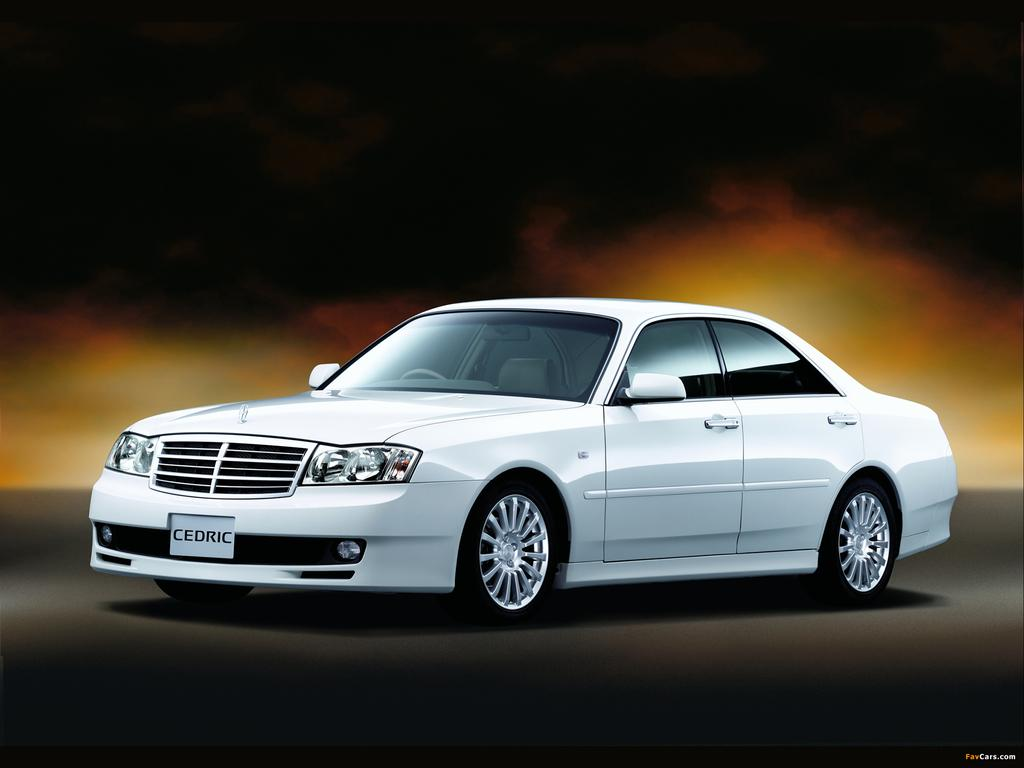What color is the car in the image? The car in the image is white. Where is the car located in the image? The car is parked on the ground. What can be observed about the background of the image? The background of the image is dark. How does the car's income affect the visibility of the lake in the image? There is no lake present in the image, and the car's income is not mentioned, so it cannot be determined how it would affect the visibility of a lake. 